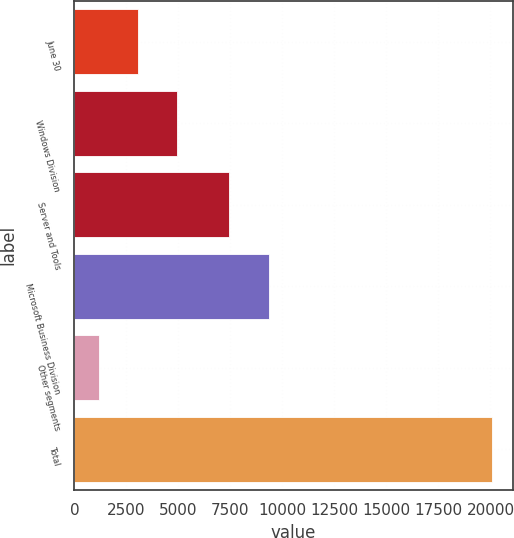Convert chart. <chart><loc_0><loc_0><loc_500><loc_500><bar_chart><fcel>June 30<fcel>Windows Division<fcel>Server and Tools<fcel>Microsoft Business Division<fcel>Other segments<fcel>Total<nl><fcel>3045.4<fcel>4935.8<fcel>7445<fcel>9335.4<fcel>1155<fcel>20059<nl></chart> 